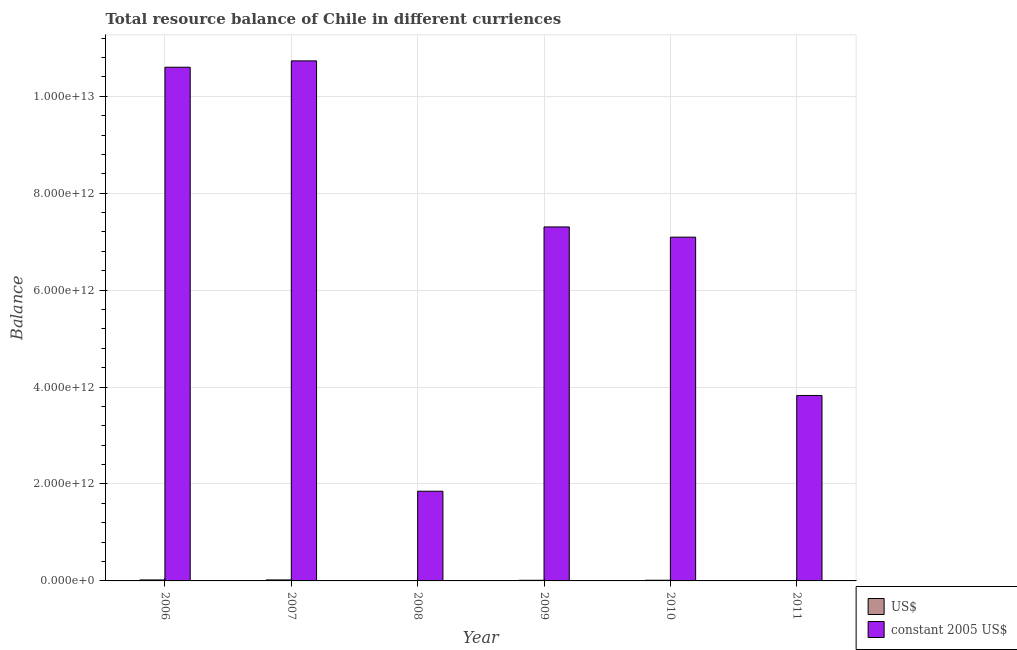How many groups of bars are there?
Make the answer very short. 6. Are the number of bars per tick equal to the number of legend labels?
Your response must be concise. Yes. How many bars are there on the 2nd tick from the left?
Provide a short and direct response. 2. What is the resource balance in constant us$ in 2009?
Give a very brief answer. 7.30e+12. Across all years, what is the maximum resource balance in us$?
Offer a terse response. 2.05e+1. Across all years, what is the minimum resource balance in us$?
Give a very brief answer. 3.54e+09. In which year was the resource balance in constant us$ minimum?
Your answer should be compact. 2008. What is the total resource balance in constant us$ in the graph?
Provide a short and direct response. 4.14e+13. What is the difference between the resource balance in constant us$ in 2006 and that in 2010?
Give a very brief answer. 3.51e+12. What is the difference between the resource balance in us$ in 2009 and the resource balance in constant us$ in 2010?
Offer a terse response. -8.79e+08. What is the average resource balance in constant us$ per year?
Your answer should be very brief. 6.90e+12. In the year 2009, what is the difference between the resource balance in constant us$ and resource balance in us$?
Your response must be concise. 0. In how many years, is the resource balance in us$ greater than 8400000000000 units?
Make the answer very short. 0. What is the ratio of the resource balance in constant us$ in 2008 to that in 2011?
Provide a short and direct response. 0.48. Is the resource balance in us$ in 2007 less than that in 2010?
Provide a succinct answer. No. Is the difference between the resource balance in us$ in 2010 and 2011 greater than the difference between the resource balance in constant us$ in 2010 and 2011?
Offer a very short reply. No. What is the difference between the highest and the second highest resource balance in constant us$?
Ensure brevity in your answer.  1.31e+11. What is the difference between the highest and the lowest resource balance in us$?
Offer a terse response. 1.70e+1. In how many years, is the resource balance in constant us$ greater than the average resource balance in constant us$ taken over all years?
Your response must be concise. 4. What does the 2nd bar from the left in 2011 represents?
Your response must be concise. Constant 2005 us$. What does the 2nd bar from the right in 2008 represents?
Offer a terse response. US$. How many bars are there?
Give a very brief answer. 12. Are all the bars in the graph horizontal?
Make the answer very short. No. How many years are there in the graph?
Ensure brevity in your answer.  6. What is the difference between two consecutive major ticks on the Y-axis?
Offer a very short reply. 2.00e+12. Does the graph contain any zero values?
Your answer should be compact. No. Does the graph contain grids?
Keep it short and to the point. Yes. How many legend labels are there?
Offer a very short reply. 2. How are the legend labels stacked?
Give a very brief answer. Vertical. What is the title of the graph?
Your answer should be compact. Total resource balance of Chile in different curriences. Does "Boys" appear as one of the legend labels in the graph?
Provide a short and direct response. No. What is the label or title of the X-axis?
Provide a succinct answer. Year. What is the label or title of the Y-axis?
Provide a short and direct response. Balance. What is the Balance in US$ in 2006?
Your response must be concise. 2.00e+1. What is the Balance in constant 2005 US$ in 2006?
Your answer should be very brief. 1.06e+13. What is the Balance of US$ in 2007?
Give a very brief answer. 2.05e+1. What is the Balance of constant 2005 US$ in 2007?
Make the answer very short. 1.07e+13. What is the Balance in US$ in 2008?
Offer a terse response. 3.54e+09. What is the Balance in constant 2005 US$ in 2008?
Keep it short and to the point. 1.85e+12. What is the Balance in US$ in 2009?
Offer a very short reply. 1.30e+1. What is the Balance in constant 2005 US$ in 2009?
Keep it short and to the point. 7.30e+12. What is the Balance in US$ in 2010?
Your answer should be compact. 1.39e+1. What is the Balance of constant 2005 US$ in 2010?
Offer a terse response. 7.09e+12. What is the Balance of US$ in 2011?
Make the answer very short. 7.91e+09. What is the Balance of constant 2005 US$ in 2011?
Provide a short and direct response. 3.83e+12. Across all years, what is the maximum Balance of US$?
Provide a short and direct response. 2.05e+1. Across all years, what is the maximum Balance in constant 2005 US$?
Offer a very short reply. 1.07e+13. Across all years, what is the minimum Balance in US$?
Offer a terse response. 3.54e+09. Across all years, what is the minimum Balance in constant 2005 US$?
Ensure brevity in your answer.  1.85e+12. What is the total Balance in US$ in the graph?
Provide a succinct answer. 7.89e+1. What is the total Balance of constant 2005 US$ in the graph?
Offer a terse response. 4.14e+13. What is the difference between the Balance of US$ in 2006 and that in 2007?
Provide a short and direct response. -5.50e+08. What is the difference between the Balance of constant 2005 US$ in 2006 and that in 2007?
Your answer should be compact. -1.31e+11. What is the difference between the Balance in US$ in 2006 and that in 2008?
Your response must be concise. 1.64e+1. What is the difference between the Balance of constant 2005 US$ in 2006 and that in 2008?
Keep it short and to the point. 8.75e+12. What is the difference between the Balance in US$ in 2006 and that in 2009?
Give a very brief answer. 6.97e+09. What is the difference between the Balance of constant 2005 US$ in 2006 and that in 2009?
Offer a very short reply. 3.30e+12. What is the difference between the Balance of US$ in 2006 and that in 2010?
Your answer should be compact. 6.09e+09. What is the difference between the Balance of constant 2005 US$ in 2006 and that in 2010?
Provide a succinct answer. 3.51e+12. What is the difference between the Balance of US$ in 2006 and that in 2011?
Ensure brevity in your answer.  1.21e+1. What is the difference between the Balance of constant 2005 US$ in 2006 and that in 2011?
Keep it short and to the point. 6.77e+12. What is the difference between the Balance in US$ in 2007 and that in 2008?
Keep it short and to the point. 1.70e+1. What is the difference between the Balance in constant 2005 US$ in 2007 and that in 2008?
Make the answer very short. 8.88e+12. What is the difference between the Balance in US$ in 2007 and that in 2009?
Give a very brief answer. 7.51e+09. What is the difference between the Balance in constant 2005 US$ in 2007 and that in 2009?
Your response must be concise. 3.43e+12. What is the difference between the Balance in US$ in 2007 and that in 2010?
Provide a succinct answer. 6.64e+09. What is the difference between the Balance in constant 2005 US$ in 2007 and that in 2010?
Ensure brevity in your answer.  3.64e+12. What is the difference between the Balance of US$ in 2007 and that in 2011?
Provide a succinct answer. 1.26e+1. What is the difference between the Balance of constant 2005 US$ in 2007 and that in 2011?
Make the answer very short. 6.90e+12. What is the difference between the Balance of US$ in 2008 and that in 2009?
Make the answer very short. -9.48e+09. What is the difference between the Balance of constant 2005 US$ in 2008 and that in 2009?
Give a very brief answer. -5.45e+12. What is the difference between the Balance of US$ in 2008 and that in 2010?
Make the answer very short. -1.04e+1. What is the difference between the Balance of constant 2005 US$ in 2008 and that in 2010?
Keep it short and to the point. -5.24e+12. What is the difference between the Balance in US$ in 2008 and that in 2011?
Your answer should be compact. -4.37e+09. What is the difference between the Balance of constant 2005 US$ in 2008 and that in 2011?
Offer a terse response. -1.98e+12. What is the difference between the Balance of US$ in 2009 and that in 2010?
Make the answer very short. -8.79e+08. What is the difference between the Balance of constant 2005 US$ in 2009 and that in 2010?
Make the answer very short. 2.11e+11. What is the difference between the Balance of US$ in 2009 and that in 2011?
Ensure brevity in your answer.  5.11e+09. What is the difference between the Balance of constant 2005 US$ in 2009 and that in 2011?
Provide a succinct answer. 3.48e+12. What is the difference between the Balance of US$ in 2010 and that in 2011?
Provide a succinct answer. 5.99e+09. What is the difference between the Balance in constant 2005 US$ in 2010 and that in 2011?
Offer a very short reply. 3.27e+12. What is the difference between the Balance of US$ in 2006 and the Balance of constant 2005 US$ in 2007?
Give a very brief answer. -1.07e+13. What is the difference between the Balance of US$ in 2006 and the Balance of constant 2005 US$ in 2008?
Your answer should be compact. -1.83e+12. What is the difference between the Balance in US$ in 2006 and the Balance in constant 2005 US$ in 2009?
Your response must be concise. -7.28e+12. What is the difference between the Balance of US$ in 2006 and the Balance of constant 2005 US$ in 2010?
Provide a succinct answer. -7.07e+12. What is the difference between the Balance of US$ in 2006 and the Balance of constant 2005 US$ in 2011?
Offer a terse response. -3.81e+12. What is the difference between the Balance in US$ in 2007 and the Balance in constant 2005 US$ in 2008?
Your answer should be compact. -1.83e+12. What is the difference between the Balance in US$ in 2007 and the Balance in constant 2005 US$ in 2009?
Your answer should be very brief. -7.28e+12. What is the difference between the Balance of US$ in 2007 and the Balance of constant 2005 US$ in 2010?
Ensure brevity in your answer.  -7.07e+12. What is the difference between the Balance of US$ in 2007 and the Balance of constant 2005 US$ in 2011?
Give a very brief answer. -3.81e+12. What is the difference between the Balance in US$ in 2008 and the Balance in constant 2005 US$ in 2009?
Your answer should be compact. -7.30e+12. What is the difference between the Balance in US$ in 2008 and the Balance in constant 2005 US$ in 2010?
Your response must be concise. -7.09e+12. What is the difference between the Balance of US$ in 2008 and the Balance of constant 2005 US$ in 2011?
Ensure brevity in your answer.  -3.82e+12. What is the difference between the Balance of US$ in 2009 and the Balance of constant 2005 US$ in 2010?
Keep it short and to the point. -7.08e+12. What is the difference between the Balance in US$ in 2009 and the Balance in constant 2005 US$ in 2011?
Give a very brief answer. -3.81e+12. What is the difference between the Balance of US$ in 2010 and the Balance of constant 2005 US$ in 2011?
Your response must be concise. -3.81e+12. What is the average Balance of US$ per year?
Your answer should be compact. 1.32e+1. What is the average Balance of constant 2005 US$ per year?
Keep it short and to the point. 6.90e+12. In the year 2006, what is the difference between the Balance of US$ and Balance of constant 2005 US$?
Give a very brief answer. -1.06e+13. In the year 2007, what is the difference between the Balance of US$ and Balance of constant 2005 US$?
Provide a short and direct response. -1.07e+13. In the year 2008, what is the difference between the Balance in US$ and Balance in constant 2005 US$?
Keep it short and to the point. -1.85e+12. In the year 2009, what is the difference between the Balance of US$ and Balance of constant 2005 US$?
Provide a succinct answer. -7.29e+12. In the year 2010, what is the difference between the Balance of US$ and Balance of constant 2005 US$?
Keep it short and to the point. -7.08e+12. In the year 2011, what is the difference between the Balance in US$ and Balance in constant 2005 US$?
Provide a succinct answer. -3.82e+12. What is the ratio of the Balance in US$ in 2006 to that in 2007?
Provide a short and direct response. 0.97. What is the ratio of the Balance of US$ in 2006 to that in 2008?
Your answer should be very brief. 5.64. What is the ratio of the Balance in constant 2005 US$ in 2006 to that in 2008?
Your answer should be compact. 5.73. What is the ratio of the Balance in US$ in 2006 to that in 2009?
Offer a very short reply. 1.53. What is the ratio of the Balance in constant 2005 US$ in 2006 to that in 2009?
Your answer should be compact. 1.45. What is the ratio of the Balance in US$ in 2006 to that in 2010?
Your answer should be very brief. 1.44. What is the ratio of the Balance in constant 2005 US$ in 2006 to that in 2010?
Provide a short and direct response. 1.49. What is the ratio of the Balance in US$ in 2006 to that in 2011?
Provide a short and direct response. 2.53. What is the ratio of the Balance of constant 2005 US$ in 2006 to that in 2011?
Offer a terse response. 2.77. What is the ratio of the Balance of US$ in 2007 to that in 2008?
Give a very brief answer. 5.8. What is the ratio of the Balance of constant 2005 US$ in 2007 to that in 2008?
Your answer should be very brief. 5.8. What is the ratio of the Balance of US$ in 2007 to that in 2009?
Offer a very short reply. 1.58. What is the ratio of the Balance in constant 2005 US$ in 2007 to that in 2009?
Keep it short and to the point. 1.47. What is the ratio of the Balance of US$ in 2007 to that in 2010?
Your answer should be compact. 1.48. What is the ratio of the Balance in constant 2005 US$ in 2007 to that in 2010?
Offer a very short reply. 1.51. What is the ratio of the Balance of US$ in 2007 to that in 2011?
Give a very brief answer. 2.6. What is the ratio of the Balance in constant 2005 US$ in 2007 to that in 2011?
Offer a terse response. 2.8. What is the ratio of the Balance in US$ in 2008 to that in 2009?
Provide a short and direct response. 0.27. What is the ratio of the Balance of constant 2005 US$ in 2008 to that in 2009?
Ensure brevity in your answer.  0.25. What is the ratio of the Balance in US$ in 2008 to that in 2010?
Offer a terse response. 0.25. What is the ratio of the Balance of constant 2005 US$ in 2008 to that in 2010?
Give a very brief answer. 0.26. What is the ratio of the Balance of US$ in 2008 to that in 2011?
Keep it short and to the point. 0.45. What is the ratio of the Balance in constant 2005 US$ in 2008 to that in 2011?
Give a very brief answer. 0.48. What is the ratio of the Balance in US$ in 2009 to that in 2010?
Provide a succinct answer. 0.94. What is the ratio of the Balance of constant 2005 US$ in 2009 to that in 2010?
Your answer should be very brief. 1.03. What is the ratio of the Balance in US$ in 2009 to that in 2011?
Give a very brief answer. 1.65. What is the ratio of the Balance in constant 2005 US$ in 2009 to that in 2011?
Keep it short and to the point. 1.91. What is the ratio of the Balance of US$ in 2010 to that in 2011?
Offer a very short reply. 1.76. What is the ratio of the Balance of constant 2005 US$ in 2010 to that in 2011?
Give a very brief answer. 1.85. What is the difference between the highest and the second highest Balance in US$?
Ensure brevity in your answer.  5.50e+08. What is the difference between the highest and the second highest Balance of constant 2005 US$?
Offer a terse response. 1.31e+11. What is the difference between the highest and the lowest Balance in US$?
Give a very brief answer. 1.70e+1. What is the difference between the highest and the lowest Balance of constant 2005 US$?
Provide a short and direct response. 8.88e+12. 